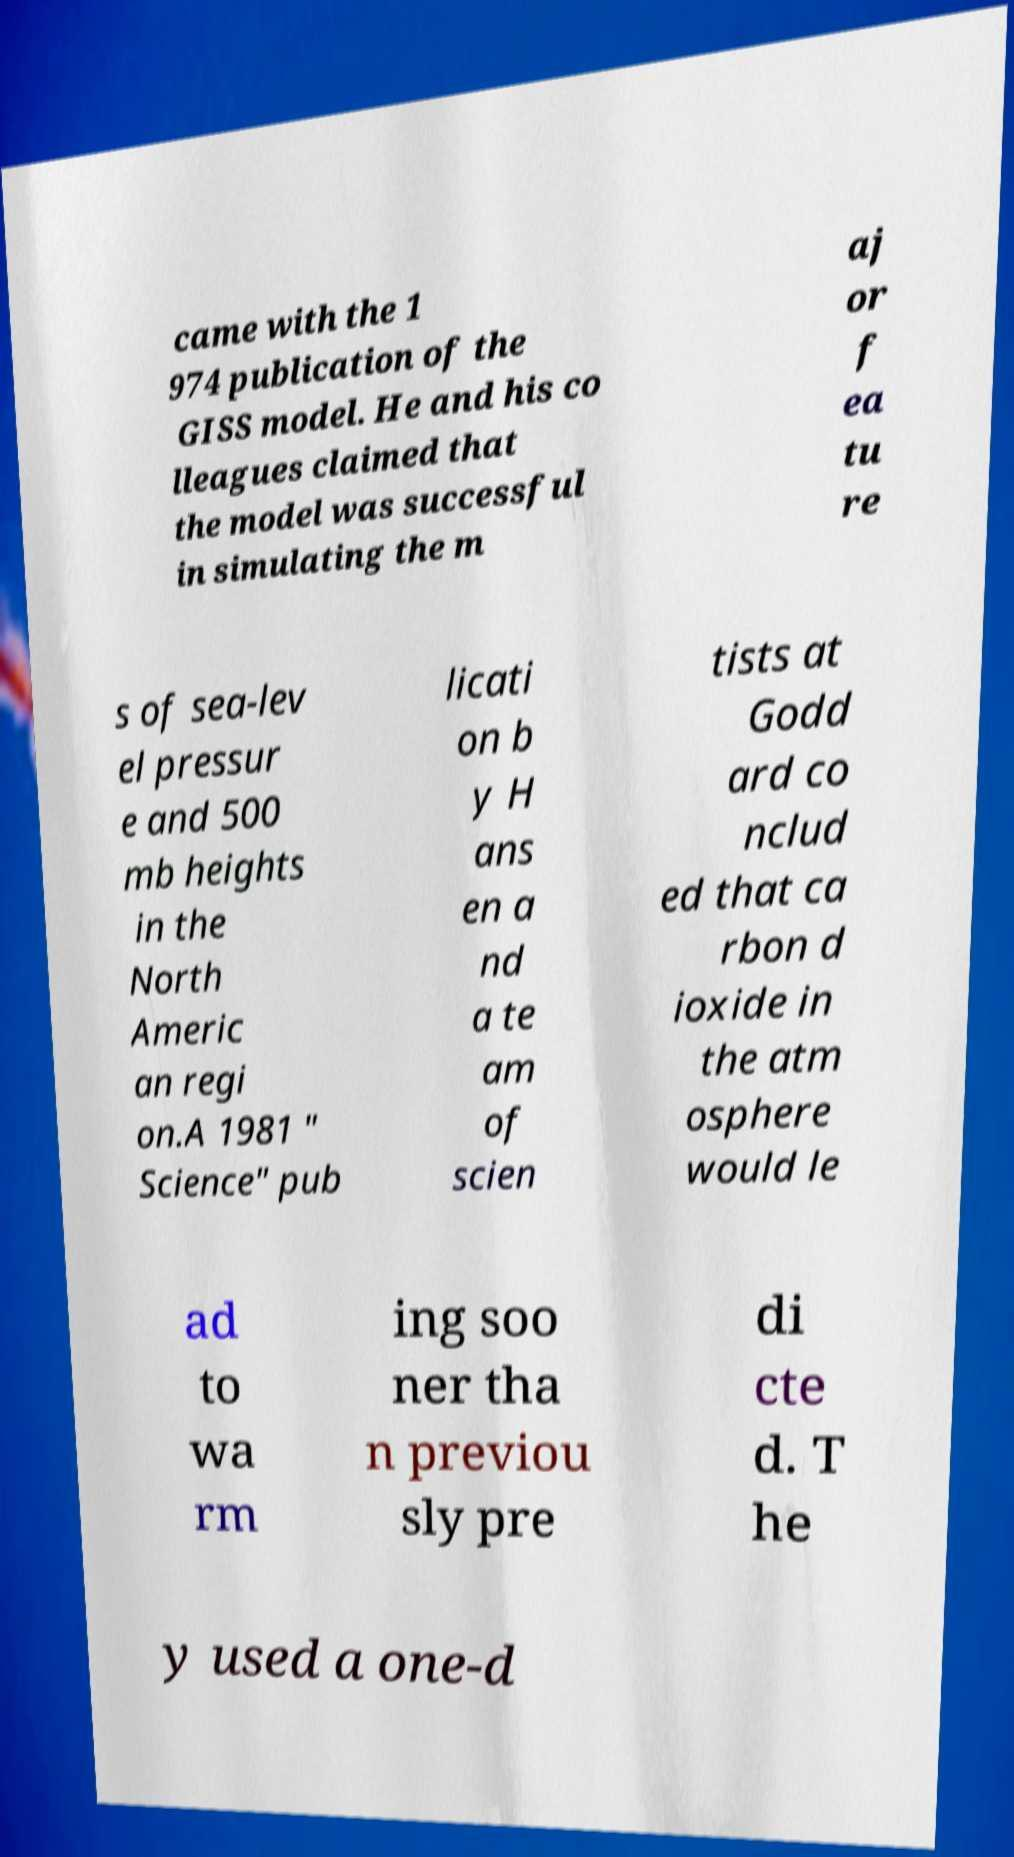I need the written content from this picture converted into text. Can you do that? came with the 1 974 publication of the GISS model. He and his co lleagues claimed that the model was successful in simulating the m aj or f ea tu re s of sea-lev el pressur e and 500 mb heights in the North Americ an regi on.A 1981 " Science" pub licati on b y H ans en a nd a te am of scien tists at Godd ard co nclud ed that ca rbon d ioxide in the atm osphere would le ad to wa rm ing soo ner tha n previou sly pre di cte d. T he y used a one-d 